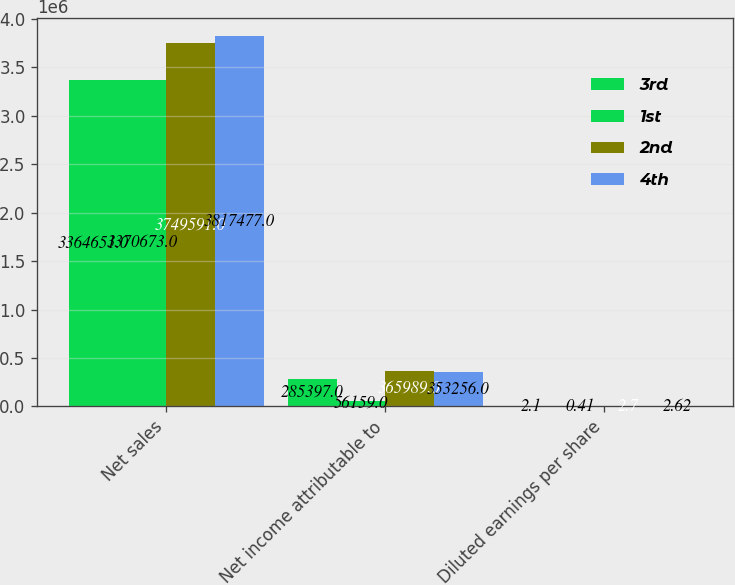<chart> <loc_0><loc_0><loc_500><loc_500><stacked_bar_chart><ecel><fcel>Net sales<fcel>Net income attributable to<fcel>Diluted earnings per share<nl><fcel>3rd<fcel>3.36465e+06<fcel>285397<fcel>2.1<nl><fcel>1st<fcel>3.37067e+06<fcel>56159<fcel>0.41<nl><fcel>2nd<fcel>3.74959e+06<fcel>365989<fcel>2.7<nl><fcel>4th<fcel>3.81748e+06<fcel>353256<fcel>2.62<nl></chart> 